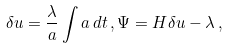<formula> <loc_0><loc_0><loc_500><loc_500>\delta u = \frac { \lambda } { a } \int a \, d t \, , \Psi = H \delta u - \lambda \, ,</formula> 